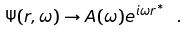Convert formula to latex. <formula><loc_0><loc_0><loc_500><loc_500>\Psi ( r , \omega ) \rightarrow A ( \omega ) e ^ { i \omega r ^ { * } } \ .</formula> 